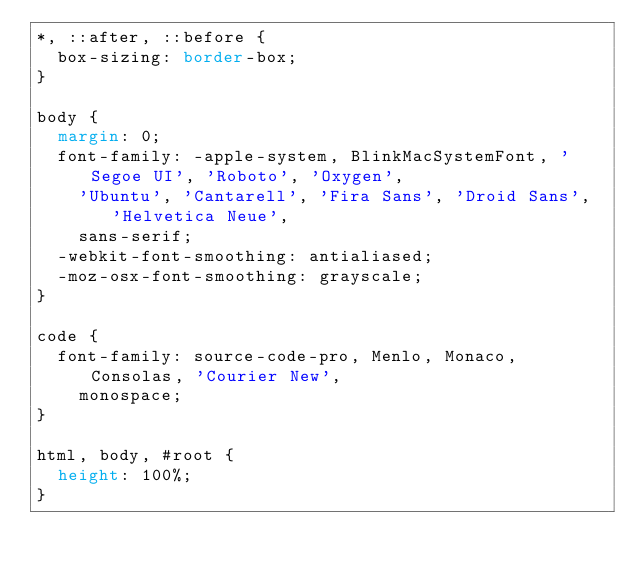Convert code to text. <code><loc_0><loc_0><loc_500><loc_500><_CSS_>*, ::after, ::before {
  box-sizing: border-box;
}

body {
  margin: 0;
  font-family: -apple-system, BlinkMacSystemFont, 'Segoe UI', 'Roboto', 'Oxygen',
    'Ubuntu', 'Cantarell', 'Fira Sans', 'Droid Sans', 'Helvetica Neue',
    sans-serif;
  -webkit-font-smoothing: antialiased;
  -moz-osx-font-smoothing: grayscale;
}

code {
  font-family: source-code-pro, Menlo, Monaco, Consolas, 'Courier New',
    monospace;
}

html, body, #root {
  height: 100%;
}</code> 